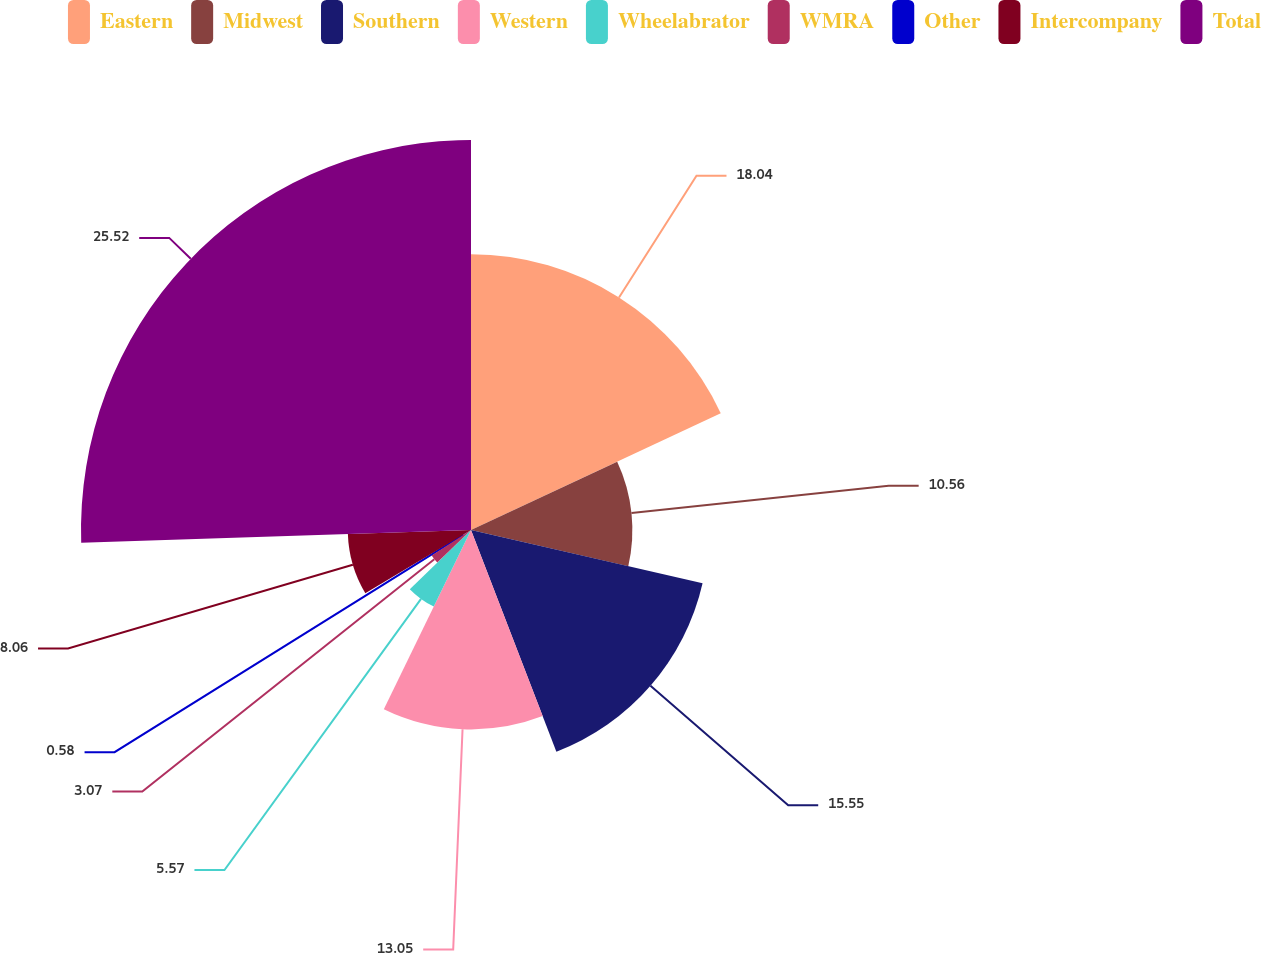<chart> <loc_0><loc_0><loc_500><loc_500><pie_chart><fcel>Eastern<fcel>Midwest<fcel>Southern<fcel>Western<fcel>Wheelabrator<fcel>WMRA<fcel>Other<fcel>Intercompany<fcel>Total<nl><fcel>18.04%<fcel>10.56%<fcel>15.55%<fcel>13.05%<fcel>5.57%<fcel>3.07%<fcel>0.58%<fcel>8.06%<fcel>25.52%<nl></chart> 